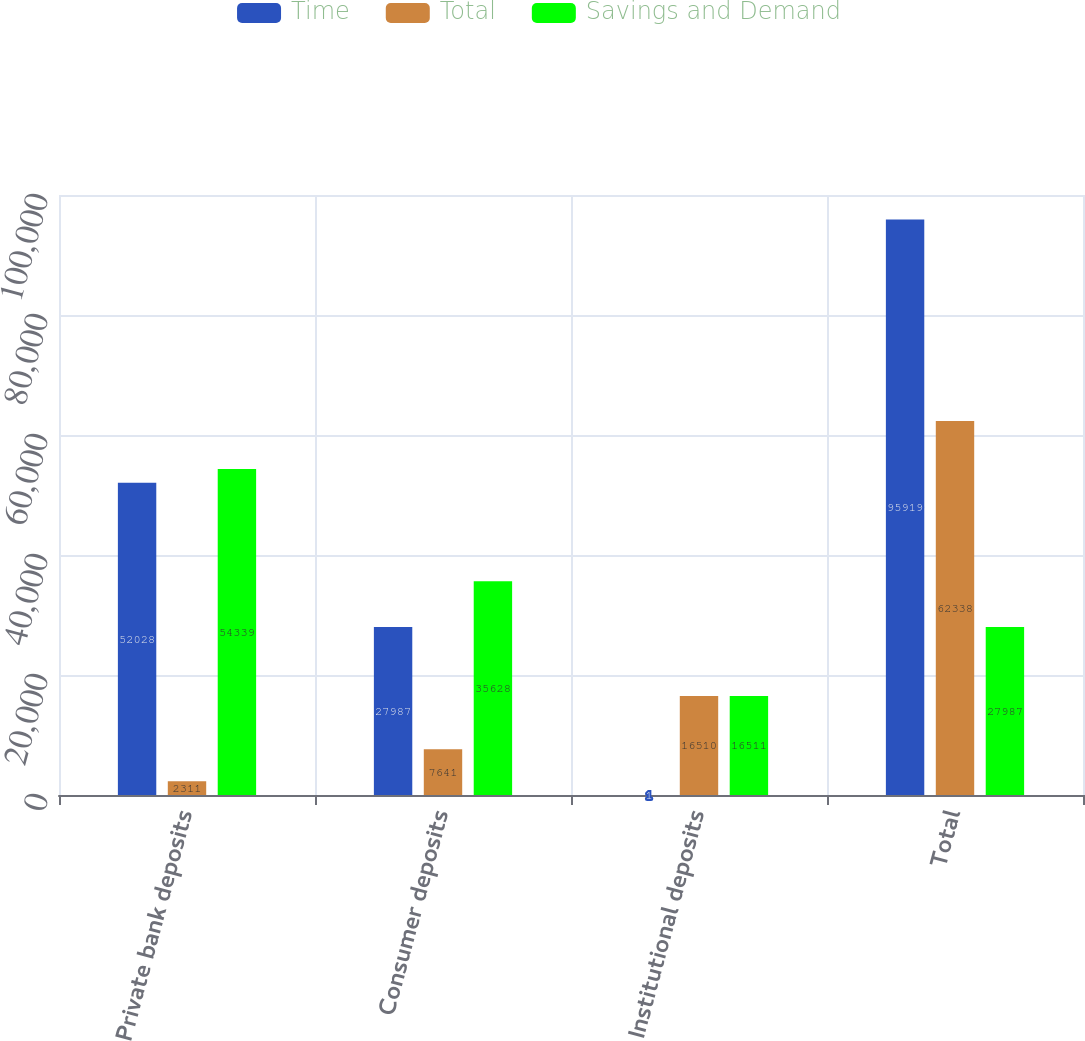<chart> <loc_0><loc_0><loc_500><loc_500><stacked_bar_chart><ecel><fcel>Private bank deposits<fcel>Consumer deposits<fcel>Institutional deposits<fcel>Total<nl><fcel>Time<fcel>52028<fcel>27987<fcel>1<fcel>95919<nl><fcel>Total<fcel>2311<fcel>7641<fcel>16510<fcel>62338<nl><fcel>Savings and Demand<fcel>54339<fcel>35628<fcel>16511<fcel>27987<nl></chart> 